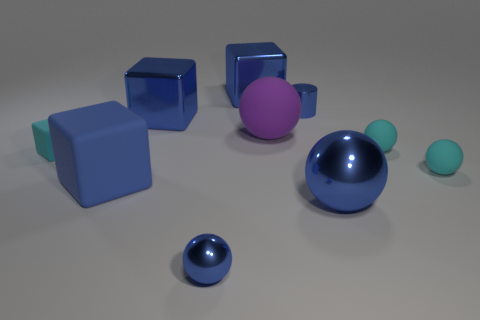How many blue blocks must be subtracted to get 1 blue blocks? 2 Subtract all blue spheres. How many blue blocks are left? 3 Subtract all big matte spheres. How many spheres are left? 4 Subtract all purple spheres. How many spheres are left? 4 Subtract 1 spheres. How many spheres are left? 4 Subtract all green balls. Subtract all brown cubes. How many balls are left? 5 Subtract all cubes. How many objects are left? 6 Add 3 blue spheres. How many blue spheres are left? 5 Add 3 large rubber blocks. How many large rubber blocks exist? 4 Subtract 0 brown blocks. How many objects are left? 10 